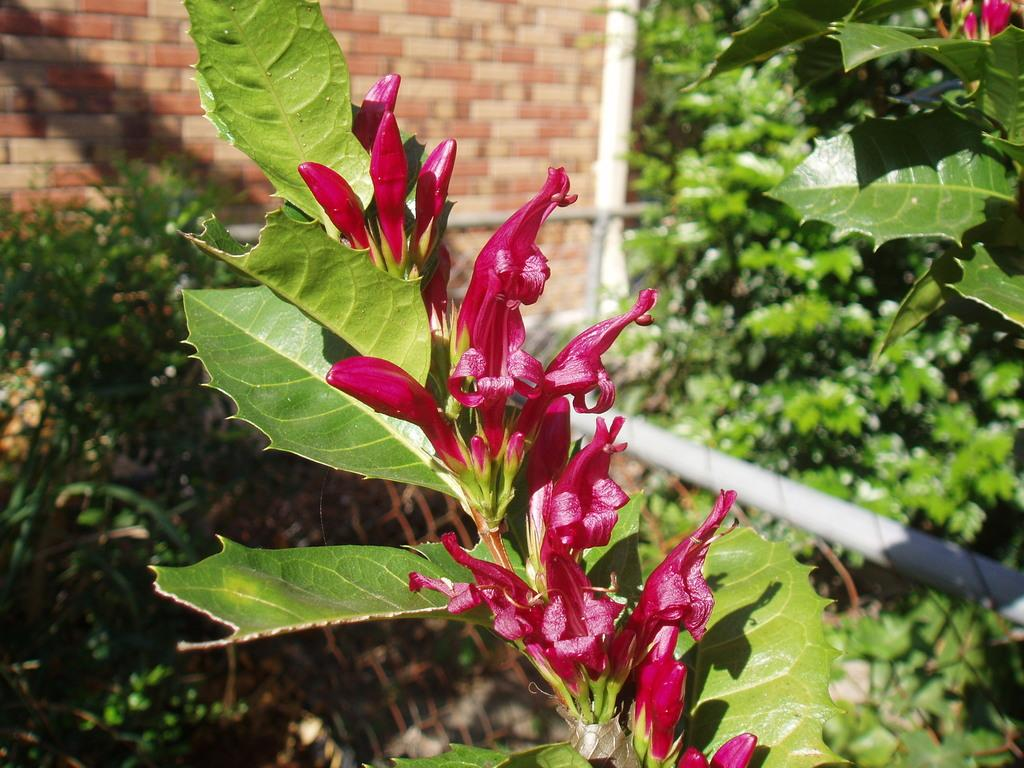What type of flowers are in the middle of the image? There are pink flowers in the middle of the image. What can be seen in the background of the image? There is a wall in the background of the image. What is located on the right side of the image? There are plants on the right side of the image. What is at the bottom of the image? There is a pole at the bottom of the image. What type of chess piece is located in the middle of the image? There is no chess piece present in the image; it features pink flowers, a wall, plants, and a pole. 